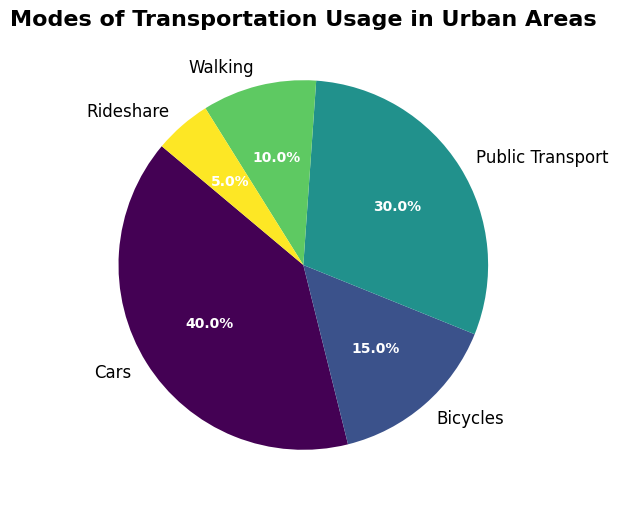What's the most commonly used mode of transportation in urban areas? By looking at the pie chart, we can see that the largest slice represents the most common mode of transportation. The largest slice is labeled "Cars," which occupies 40% of the pie.
Answer: Cars Which mode of transportation has the smallest share? By examining the pie chart, it is clear that the smallest slice corresponds to "Rideshare," which constitutes 5% of the total.
Answer: Rideshare How much larger is the percentage of Public Transport usage compared to Walking? Public Transport accounts for 30%, while Walking is 10%. By subtracting the smaller percentage from the larger one (30% - 10%), we get a difference of 20%.
Answer: 20% Which two modes of transportation together make up half of the total usage? To answer this, we need to find two modes of transportation that sum to approximately 50%. Public Transport and Cars contribute 30% and 40%, respectively. Together, 30% + 40% = 70%, which is more than 50%. Next, consider Bicycles and Walking: 15% + 10% = 25%, which is less than 50%. However, Public Transport and Bicycles together equal 30% + 15% = 45%, which is closer but still less. Finally, check Cars and Public Transport: 40% + 30% = 70%. The closest to 50% happens when combining  Public Transport and Bicycles, which offers a clearer intermediate point comparison.
Answer: Cars and Public Transport What percentage of transportation does not involve motor vehicles (excluding Cars and Rideshare)? Motor-less transportation includes Bicycles, Public Transport, and Walking. Their respective percentages are 15%, 30%, and 10%. By adding these percentages together (15% + 30% + 10%), the total is 55%.
Answer: 55% Is bicycle usage greater or lesser than walking? By how much? Bicycle usage is 15%, while walking usage is 10%. By subtracting the percentage for walking from that of bicycles (15% - 10%), the difference is 5%.
Answer: Greater by 5% Which color is used to represent Public Transport in the pie chart? As stated, the colors follow the Viridis colormap. Public Transport, having the second-largest portion, appears midway in the color gradient, typically represented by a distinct greenish hue in the Viridis palette.
Answer: Green 